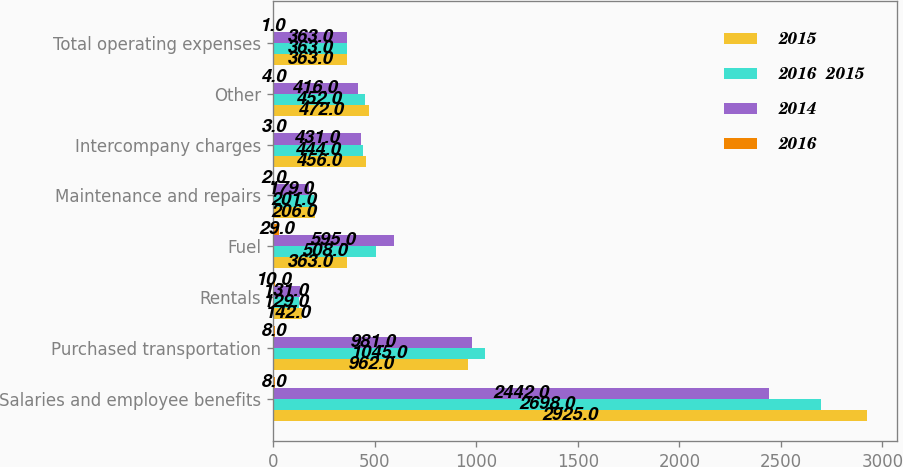<chart> <loc_0><loc_0><loc_500><loc_500><stacked_bar_chart><ecel><fcel>Salaries and employee benefits<fcel>Purchased transportation<fcel>Rentals<fcel>Fuel<fcel>Maintenance and repairs<fcel>Intercompany charges<fcel>Other<fcel>Total operating expenses<nl><fcel>2015<fcel>2925<fcel>962<fcel>142<fcel>363<fcel>206<fcel>456<fcel>472<fcel>363<nl><fcel>2016  2015<fcel>2698<fcel>1045<fcel>129<fcel>508<fcel>201<fcel>444<fcel>452<fcel>363<nl><fcel>2014<fcel>2442<fcel>981<fcel>131<fcel>595<fcel>179<fcel>431<fcel>416<fcel>363<nl><fcel>2016<fcel>8<fcel>8<fcel>10<fcel>29<fcel>2<fcel>3<fcel>4<fcel>1<nl></chart> 